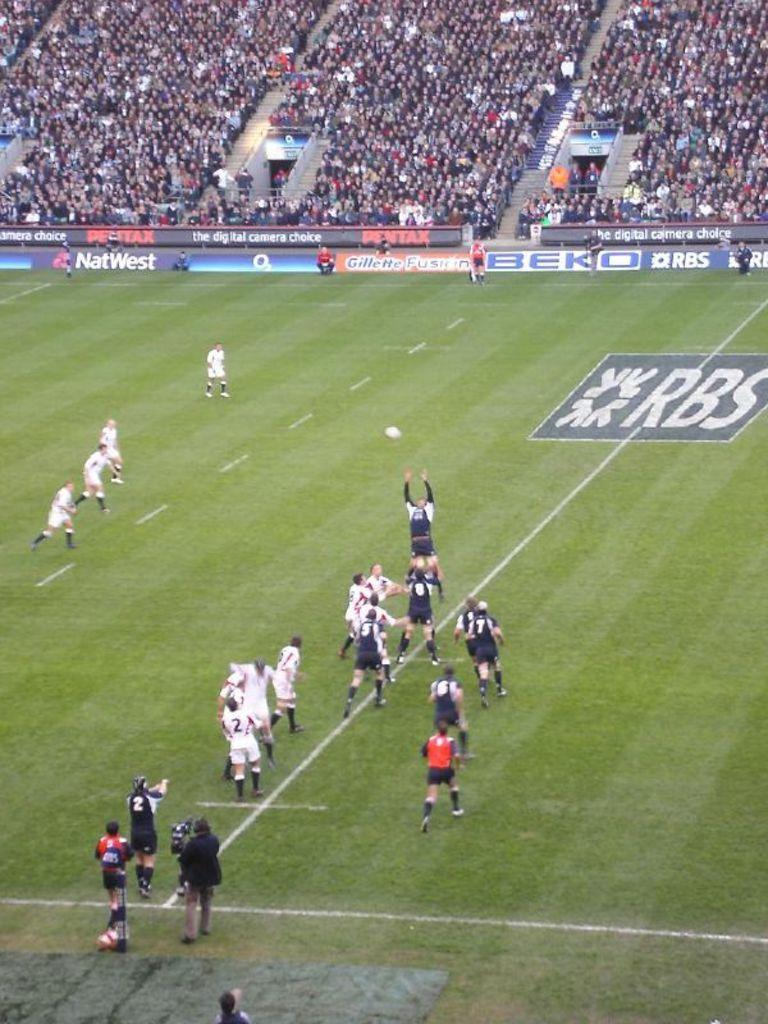<image>
Present a compact description of the photo's key features. an RBS soccer field with players in mid game mode 